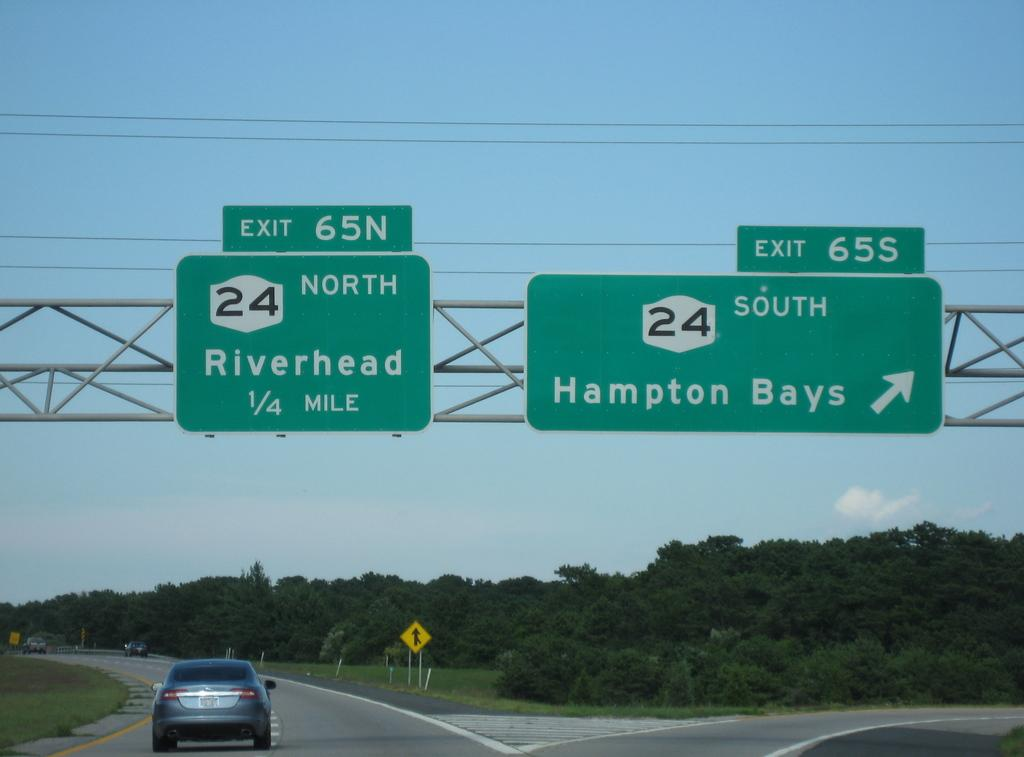What is the main subject of the image? There is a car on the road in the image. What can be seen at the bottom of the image? Trees are visible at the bottom of the image. What is located in the middle of the image? There is a sign board in the middle of the image. What is visible in the background of the image? The sky is visible in the background of the image. What is the name of the person driving the car in the image? There is no information about the driver of the car in the image, so we cannot determine their name. Can you see a coil of wire in the image? There is no coil of wire present in the image. 